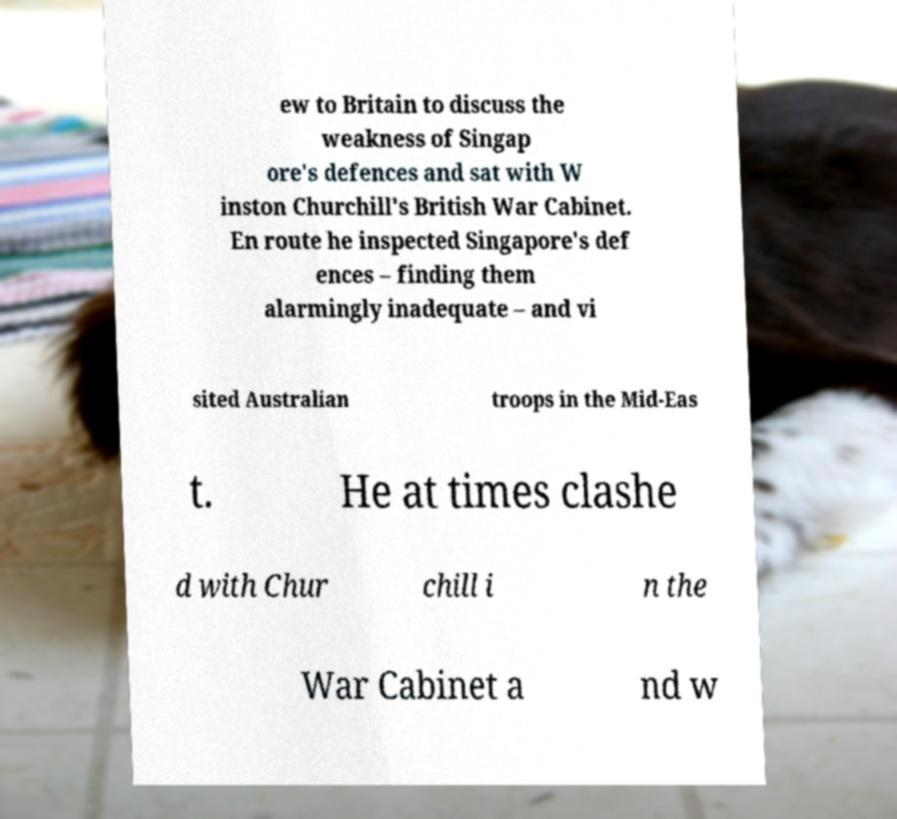I need the written content from this picture converted into text. Can you do that? ew to Britain to discuss the weakness of Singap ore's defences and sat with W inston Churchill's British War Cabinet. En route he inspected Singapore's def ences – finding them alarmingly inadequate – and vi sited Australian troops in the Mid-Eas t. He at times clashe d with Chur chill i n the War Cabinet a nd w 